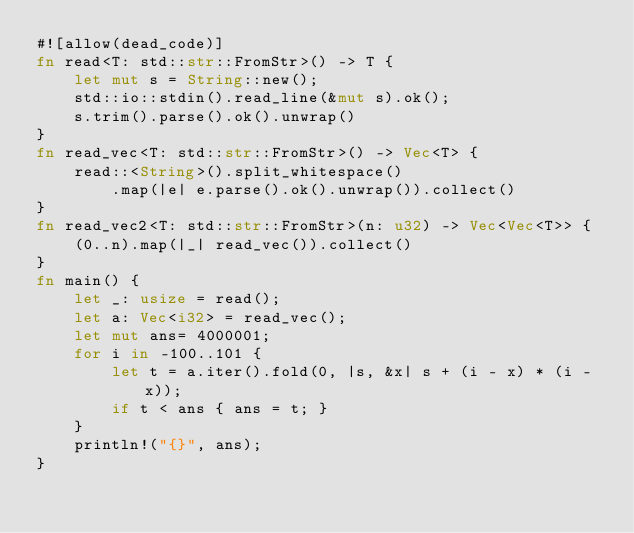Convert code to text. <code><loc_0><loc_0><loc_500><loc_500><_Rust_>#![allow(dead_code)]
fn read<T: std::str::FromStr>() -> T {
    let mut s = String::new();
    std::io::stdin().read_line(&mut s).ok();
    s.trim().parse().ok().unwrap()
}
fn read_vec<T: std::str::FromStr>() -> Vec<T> {
    read::<String>().split_whitespace()
        .map(|e| e.parse().ok().unwrap()).collect()
}
fn read_vec2<T: std::str::FromStr>(n: u32) -> Vec<Vec<T>> {
    (0..n).map(|_| read_vec()).collect()
}
fn main() {
    let _: usize = read();
    let a: Vec<i32> = read_vec();
    let mut ans= 4000001;
    for i in -100..101 {
        let t = a.iter().fold(0, |s, &x| s + (i - x) * (i - x));
        if t < ans { ans = t; }
    }
    println!("{}", ans);
}</code> 